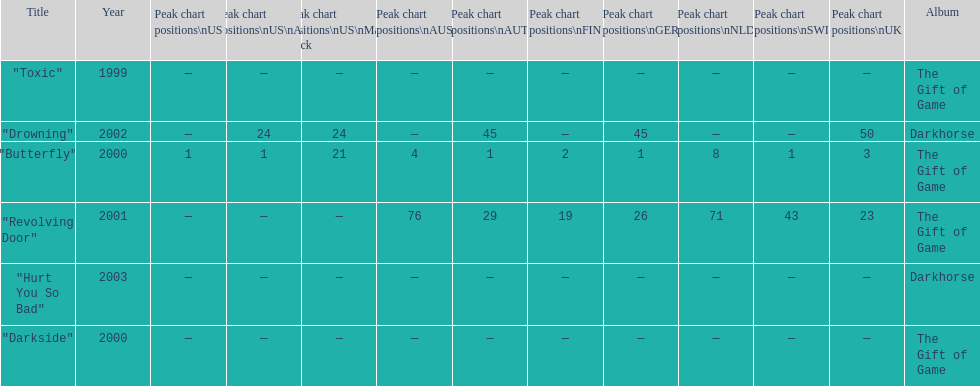By how many chart positions higher did "revolving door" peak in the uk compared to the peak position of "drowning" in the uk? 27. Help me parse the entirety of this table. {'header': ['Title', 'Year', 'Peak chart positions\\nUS', 'Peak chart positions\\nUS\\nAlt.', 'Peak chart positions\\nUS\\nMain. Rock', 'Peak chart positions\\nAUS', 'Peak chart positions\\nAUT', 'Peak chart positions\\nFIN', 'Peak chart positions\\nGER', 'Peak chart positions\\nNLD', 'Peak chart positions\\nSWI', 'Peak chart positions\\nUK', 'Album'], 'rows': [['"Toxic"', '1999', '—', '—', '—', '—', '—', '—', '—', '—', '—', '—', 'The Gift of Game'], ['"Drowning"', '2002', '—', '24', '24', '—', '45', '—', '45', '—', '—', '50', 'Darkhorse'], ['"Butterfly"', '2000', '1', '1', '21', '4', '1', '2', '1', '8', '1', '3', 'The Gift of Game'], ['"Revolving Door"', '2001', '—', '—', '—', '76', '29', '19', '26', '71', '43', '23', 'The Gift of Game'], ['"Hurt You So Bad"', '2003', '—', '—', '—', '—', '—', '—', '—', '—', '—', '—', 'Darkhorse'], ['"Darkside"', '2000', '—', '—', '—', '—', '—', '—', '—', '—', '—', '—', 'The Gift of Game']]} 